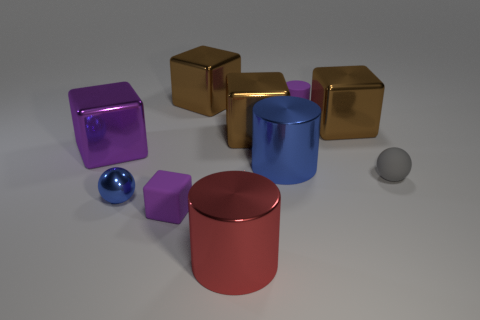Subtract all blue cylinders. How many brown cubes are left? 3 Subtract all small blocks. How many blocks are left? 4 Subtract all green blocks. Subtract all blue cylinders. How many blocks are left? 5 Subtract all cylinders. How many objects are left? 7 Add 7 tiny purple cylinders. How many tiny purple cylinders exist? 8 Subtract 0 gray cylinders. How many objects are left? 10 Subtract all blue spheres. Subtract all small spheres. How many objects are left? 7 Add 5 large blue metallic things. How many large blue metallic things are left? 6 